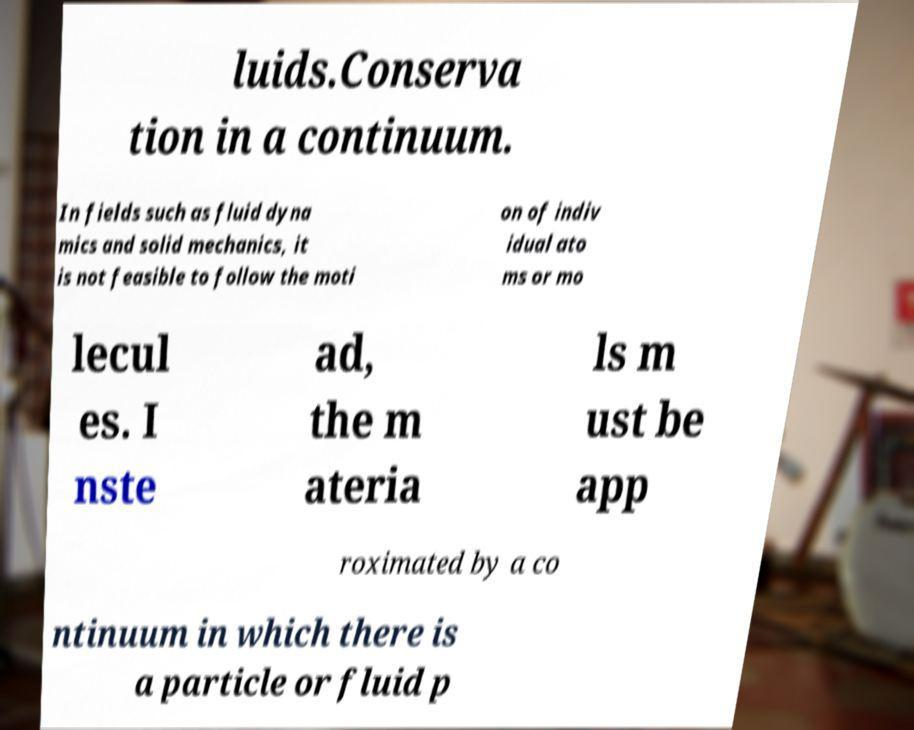Please identify and transcribe the text found in this image. luids.Conserva tion in a continuum. In fields such as fluid dyna mics and solid mechanics, it is not feasible to follow the moti on of indiv idual ato ms or mo lecul es. I nste ad, the m ateria ls m ust be app roximated by a co ntinuum in which there is a particle or fluid p 